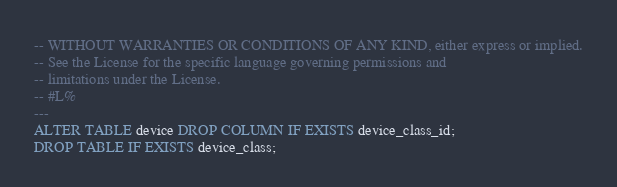<code> <loc_0><loc_0><loc_500><loc_500><_SQL_>-- WITHOUT WARRANTIES OR CONDITIONS OF ANY KIND, either express or implied.
-- See the License for the specific language governing permissions and
-- limitations under the License.
-- #L%
---
ALTER TABLE device DROP COLUMN IF EXISTS device_class_id;
DROP TABLE IF EXISTS device_class;</code> 